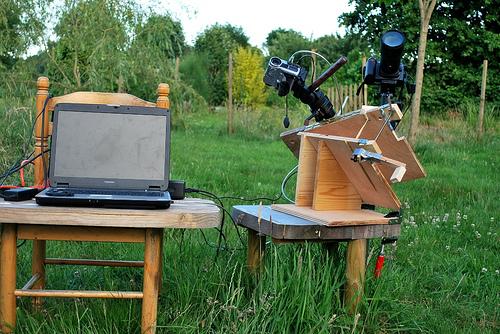What is this contraption used for?
Be succinct. Photography. How many electronic items are pictured?
Write a very short answer. 3. Is this a rural scene?
Concise answer only. Yes. 